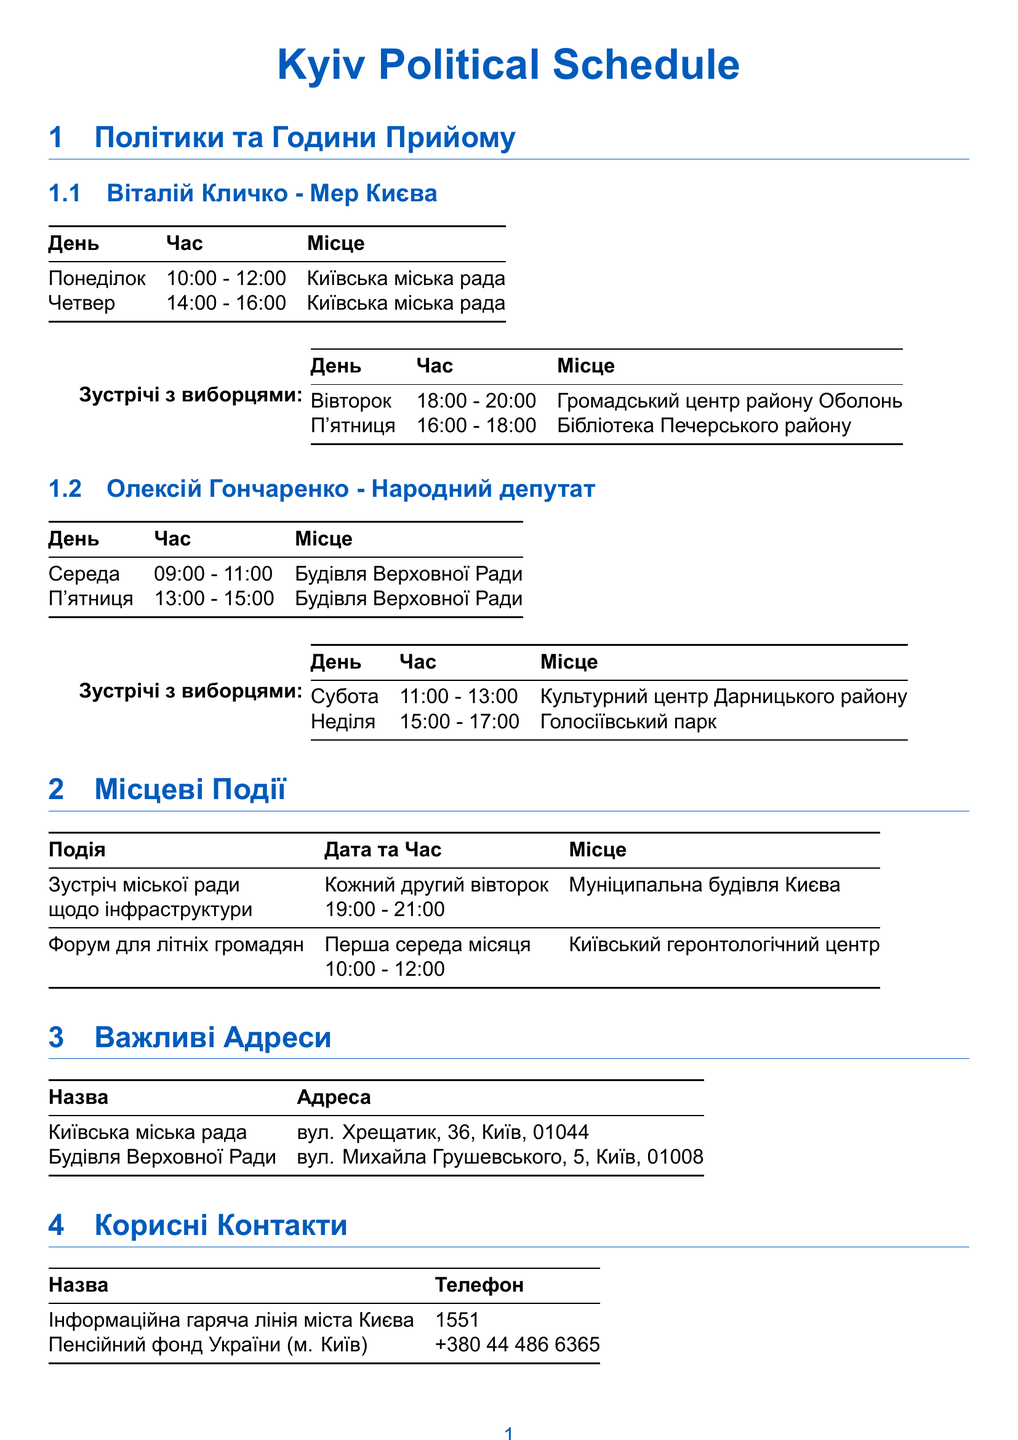What are the office hours for Vitali Klitschko? The office hours for Vitali Klitschko are listed in the document, specifically on Monday and Thursday.
Answer: Monday 10:00 - 12:00, Thursday 14:00 - 16:00 Where is Oleksiy Goncharenko's office located? The location of Oleksiy Goncharenko's office hours is provided in the document, indicating where he meets constituents.
Answer: Verkhovna Rada Building When does the Town Hall Meeting on Infrastructure occur? The schedule indicates that the Town Hall Meeting happens every second Tuesday at a specific time.
Answer: Every second Tuesday What time does the Senior Citizens' Forum take place? The document specifies the time for the Senior Citizens' Forum, allowing for a clear understanding of when it occurs.
Answer: 10:00 - 12:00 How many days a week does Vitali Klitschko hold office hours? By counting the specified office hours in the document, the number of days can be determined.
Answer: 2 days What is the phone number for the Kyiv City Information Hotline? The document provides important contact information, including the phone number for the hotline.
Answer: 1551 Which district hosts the constituent meetings on Tuesday? The meeting location for Tuesday is listed in the document, indicating the district associated with that meeting.
Answer: Obolon District Community Center On which day is the next constituent meeting with Oleksiy Goncharenko? To find this, the document can indicate the day of his next constituent meeting in the provided schedule.
Answer: Saturday Where is the Kyiv Gerontology Center located? The location of the Kyiv Gerontology Center is implied to be significant for the Senior Citizens' Forum mentioned in the document.
Answer: Kyiv Gerontology Center 